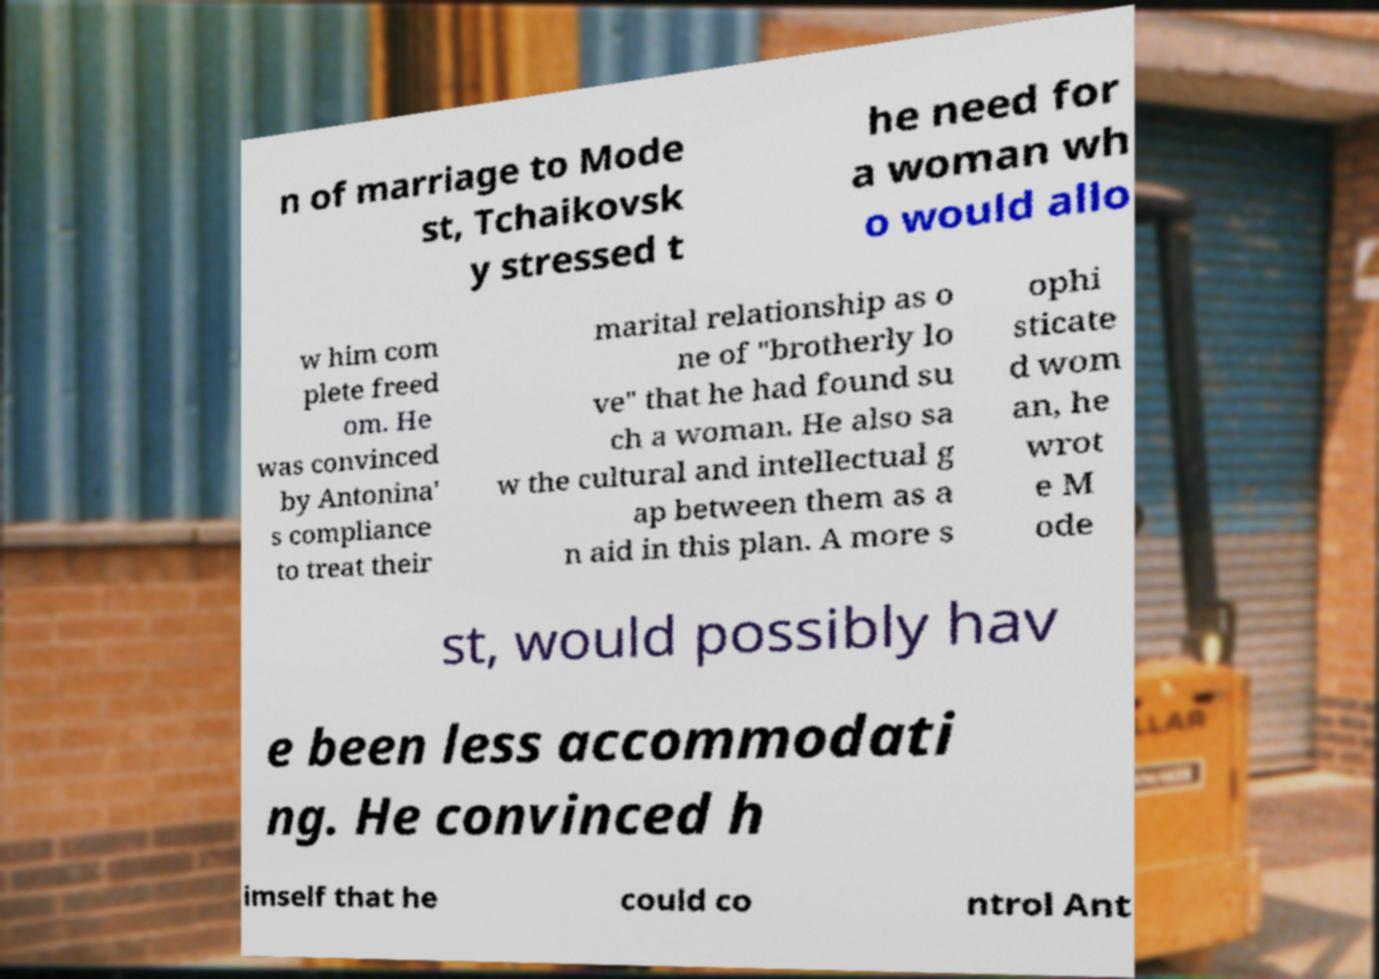I need the written content from this picture converted into text. Can you do that? n of marriage to Mode st, Tchaikovsk y stressed t he need for a woman wh o would allo w him com plete freed om. He was convinced by Antonina' s compliance to treat their marital relationship as o ne of "brotherly lo ve" that he had found su ch a woman. He also sa w the cultural and intellectual g ap between them as a n aid in this plan. A more s ophi sticate d wom an, he wrot e M ode st, would possibly hav e been less accommodati ng. He convinced h imself that he could co ntrol Ant 